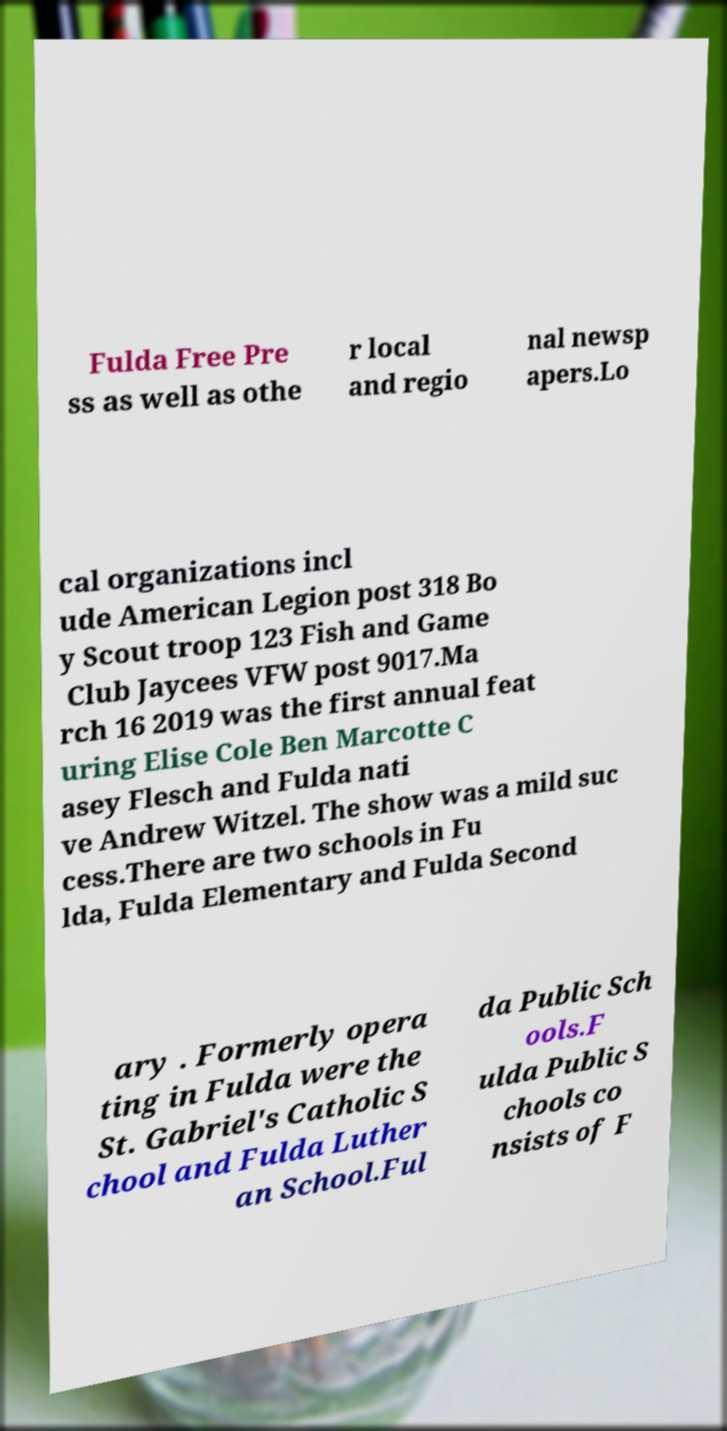Please identify and transcribe the text found in this image. Fulda Free Pre ss as well as othe r local and regio nal newsp apers.Lo cal organizations incl ude American Legion post 318 Bo y Scout troop 123 Fish and Game Club Jaycees VFW post 9017.Ma rch 16 2019 was the first annual feat uring Elise Cole Ben Marcotte C asey Flesch and Fulda nati ve Andrew Witzel. The show was a mild suc cess.There are two schools in Fu lda, Fulda Elementary and Fulda Second ary . Formerly opera ting in Fulda were the St. Gabriel's Catholic S chool and Fulda Luther an School.Ful da Public Sch ools.F ulda Public S chools co nsists of F 